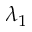<formula> <loc_0><loc_0><loc_500><loc_500>\lambda _ { 1 }</formula> 